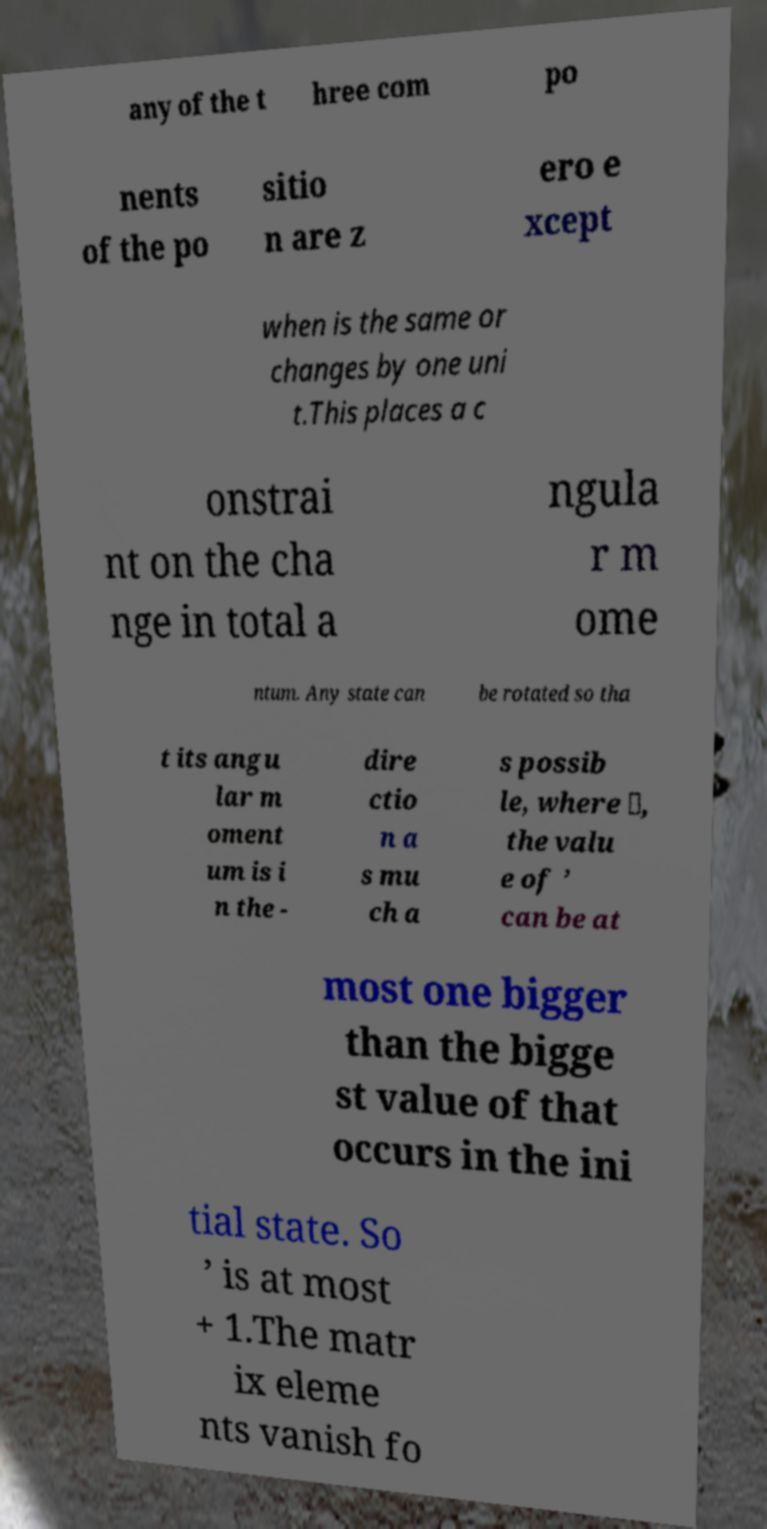I need the written content from this picture converted into text. Can you do that? any of the t hree com po nents of the po sitio n are z ero e xcept when is the same or changes by one uni t.This places a c onstrai nt on the cha nge in total a ngula r m ome ntum. Any state can be rotated so tha t its angu lar m oment um is i n the - dire ctio n a s mu ch a s possib le, where ⟩, the valu e of ’ can be at most one bigger than the bigge st value of that occurs in the ini tial state. So ’ is at most + 1.The matr ix eleme nts vanish fo 